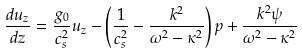Convert formula to latex. <formula><loc_0><loc_0><loc_500><loc_500>\frac { d u _ { z } } { d z } = \frac { g _ { 0 } } { c _ { s } ^ { 2 } } u _ { z } - \left ( \frac { 1 } { c _ { s } ^ { 2 } } - \frac { k ^ { 2 } } { \omega ^ { 2 } - \kappa ^ { 2 } } \right ) p + \frac { k ^ { 2 } \psi } { \omega ^ { 2 } - \kappa ^ { 2 } }</formula> 